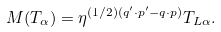<formula> <loc_0><loc_0><loc_500><loc_500>M ( T _ { \alpha } ) = \eta ^ { ( 1 / 2 ) ( q ^ { \prime } \cdot p ^ { \prime } - q \cdot p ) } T _ { L \alpha } .</formula> 